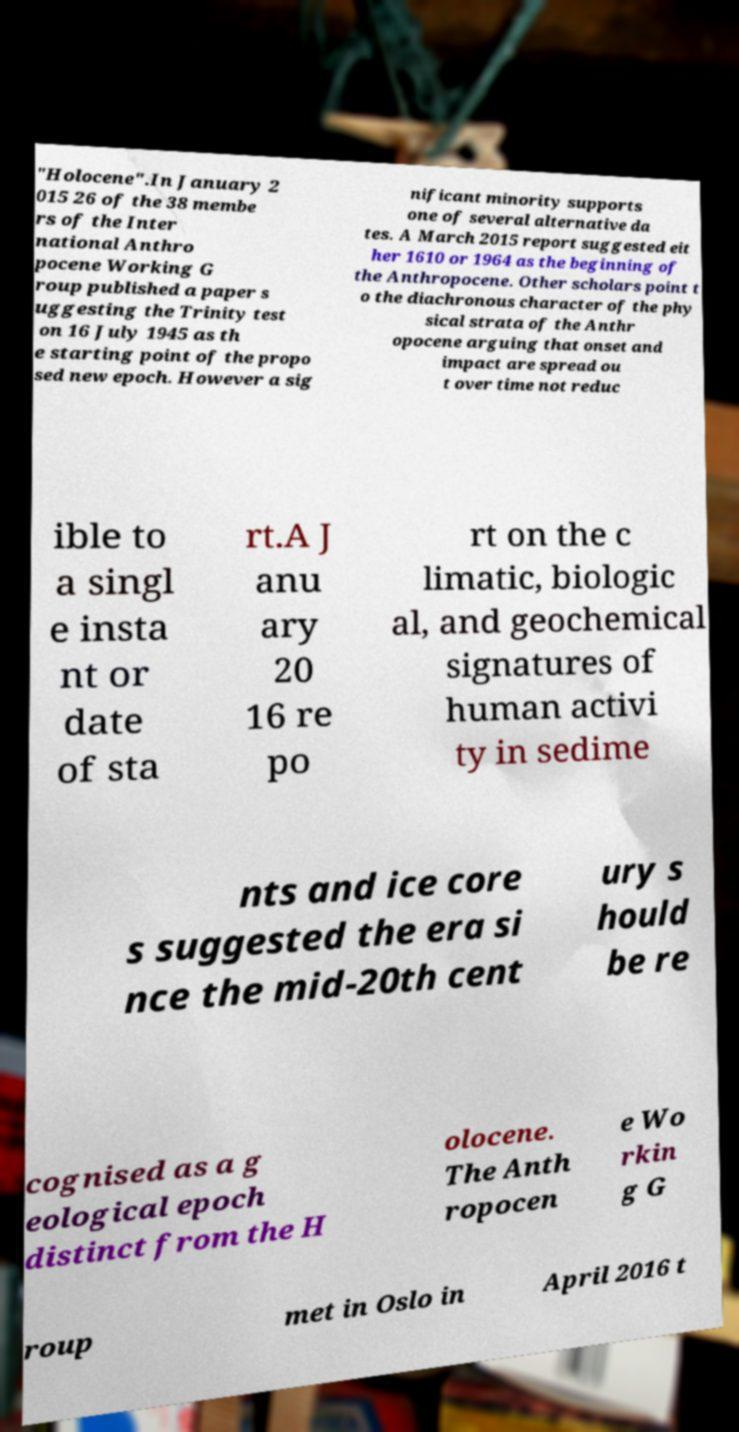Can you read and provide the text displayed in the image?This photo seems to have some interesting text. Can you extract and type it out for me? "Holocene".In January 2 015 26 of the 38 membe rs of the Inter national Anthro pocene Working G roup published a paper s uggesting the Trinity test on 16 July 1945 as th e starting point of the propo sed new epoch. However a sig nificant minority supports one of several alternative da tes. A March 2015 report suggested eit her 1610 or 1964 as the beginning of the Anthropocene. Other scholars point t o the diachronous character of the phy sical strata of the Anthr opocene arguing that onset and impact are spread ou t over time not reduc ible to a singl e insta nt or date of sta rt.A J anu ary 20 16 re po rt on the c limatic, biologic al, and geochemical signatures of human activi ty in sedime nts and ice core s suggested the era si nce the mid-20th cent ury s hould be re cognised as a g eological epoch distinct from the H olocene. The Anth ropocen e Wo rkin g G roup met in Oslo in April 2016 t 